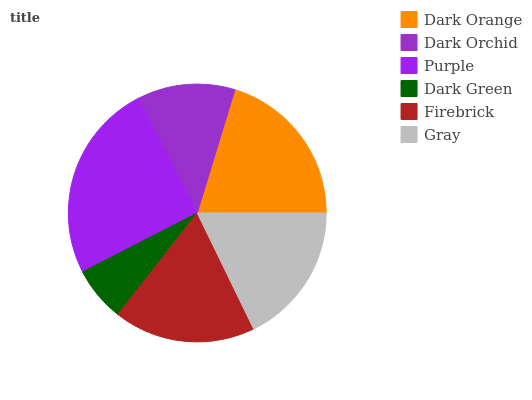Is Dark Green the minimum?
Answer yes or no. Yes. Is Purple the maximum?
Answer yes or no. Yes. Is Dark Orchid the minimum?
Answer yes or no. No. Is Dark Orchid the maximum?
Answer yes or no. No. Is Dark Orange greater than Dark Orchid?
Answer yes or no. Yes. Is Dark Orchid less than Dark Orange?
Answer yes or no. Yes. Is Dark Orchid greater than Dark Orange?
Answer yes or no. No. Is Dark Orange less than Dark Orchid?
Answer yes or no. No. Is Gray the high median?
Answer yes or no. Yes. Is Firebrick the low median?
Answer yes or no. Yes. Is Dark Green the high median?
Answer yes or no. No. Is Dark Orange the low median?
Answer yes or no. No. 